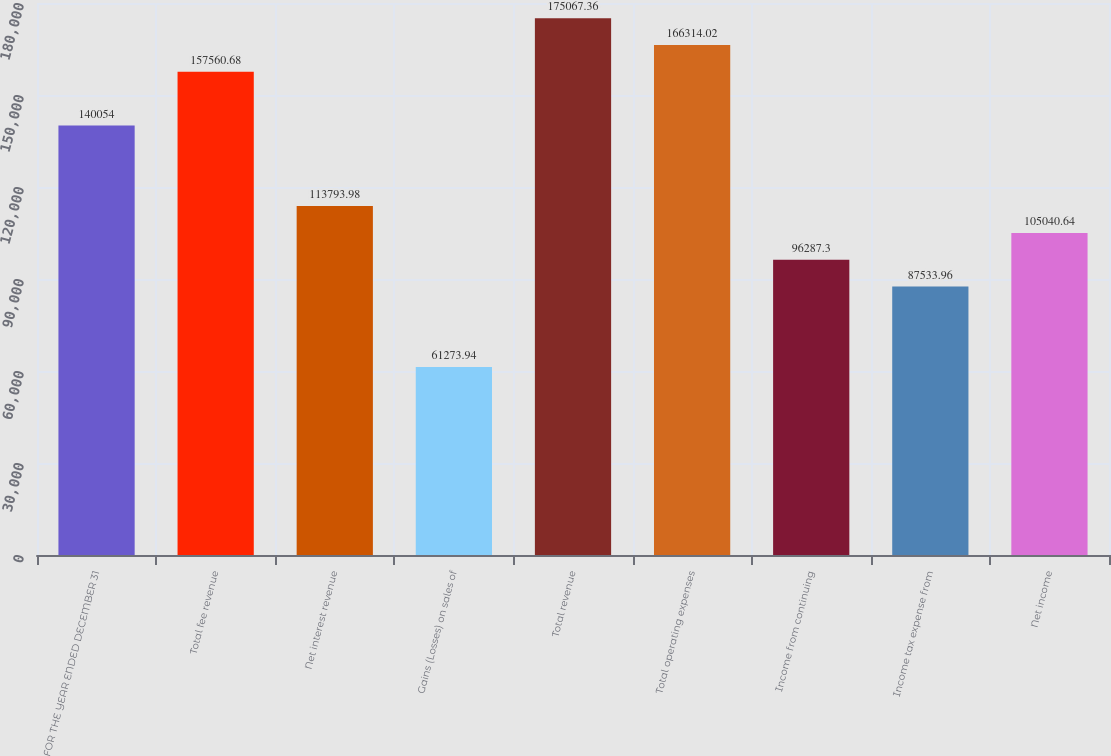Convert chart to OTSL. <chart><loc_0><loc_0><loc_500><loc_500><bar_chart><fcel>FOR THE YEAR ENDED DECEMBER 31<fcel>Total fee revenue<fcel>Net interest revenue<fcel>Gains (Losses) on sales of<fcel>Total revenue<fcel>Total operating expenses<fcel>Income from continuing<fcel>Income tax expense from<fcel>Net income<nl><fcel>140054<fcel>157561<fcel>113794<fcel>61273.9<fcel>175067<fcel>166314<fcel>96287.3<fcel>87534<fcel>105041<nl></chart> 